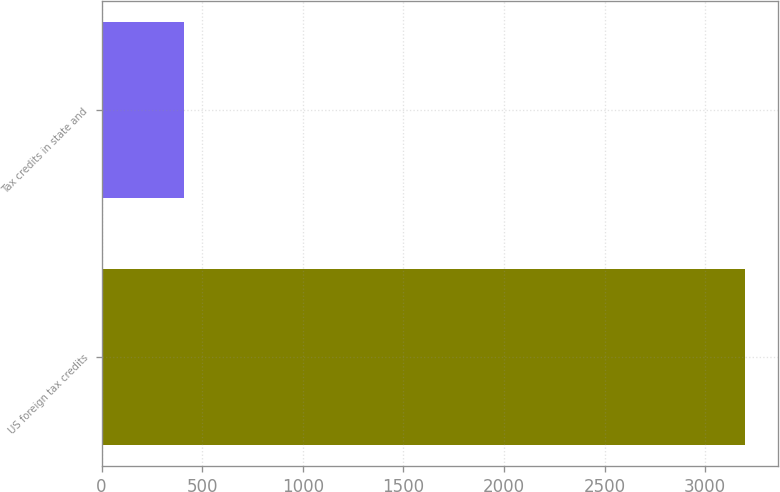Convert chart. <chart><loc_0><loc_0><loc_500><loc_500><bar_chart><fcel>US foreign tax credits<fcel>Tax credits in state and<nl><fcel>3200<fcel>408<nl></chart> 